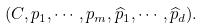Convert formula to latex. <formula><loc_0><loc_0><loc_500><loc_500>( C , p _ { 1 } , \cdots , p _ { m } , \widehat { p } _ { 1 } , \cdots , \widehat { p } _ { d } ) .</formula> 